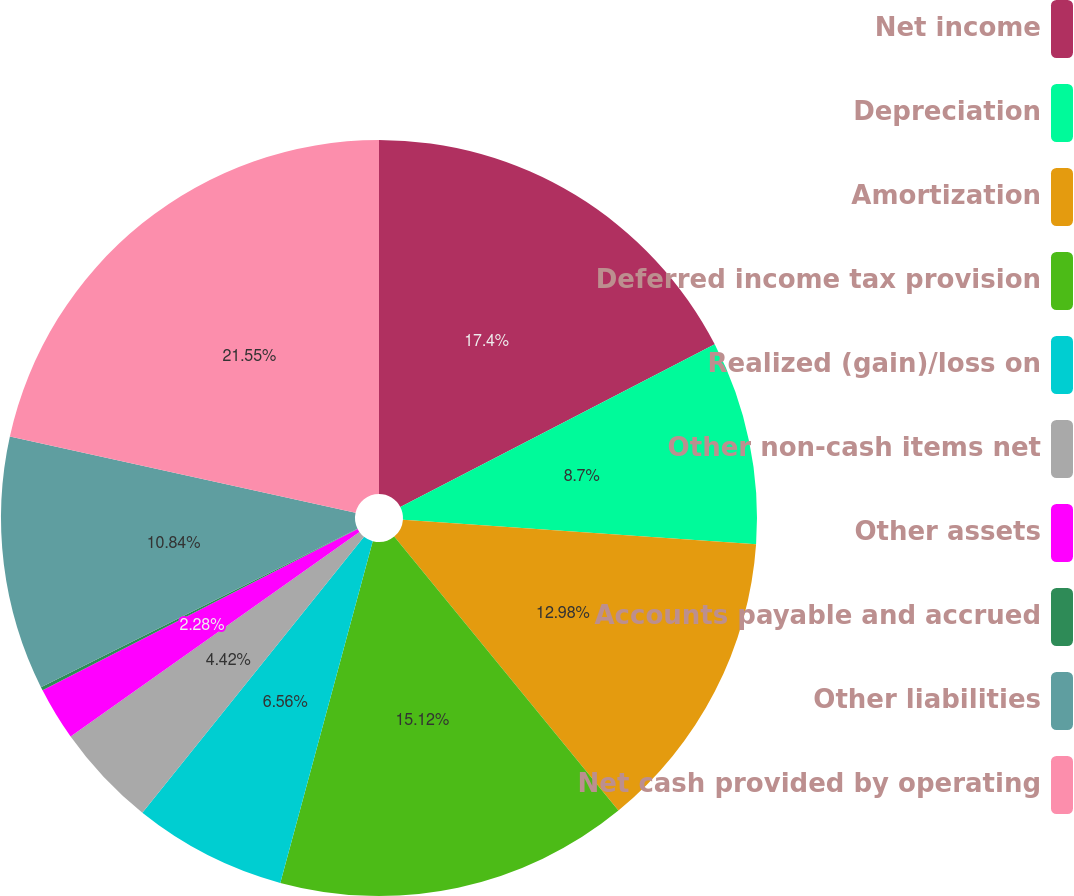Convert chart. <chart><loc_0><loc_0><loc_500><loc_500><pie_chart><fcel>Net income<fcel>Depreciation<fcel>Amortization<fcel>Deferred income tax provision<fcel>Realized (gain)/loss on<fcel>Other non-cash items net<fcel>Other assets<fcel>Accounts payable and accrued<fcel>Other liabilities<fcel>Net cash provided by operating<nl><fcel>17.4%<fcel>8.7%<fcel>12.98%<fcel>15.12%<fcel>6.56%<fcel>4.42%<fcel>2.28%<fcel>0.15%<fcel>10.84%<fcel>21.54%<nl></chart> 